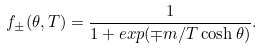<formula> <loc_0><loc_0><loc_500><loc_500>f _ { \pm } ( \theta , T ) = \frac { 1 } { 1 + e x p ( \mp m / T \cosh \theta ) } .</formula> 